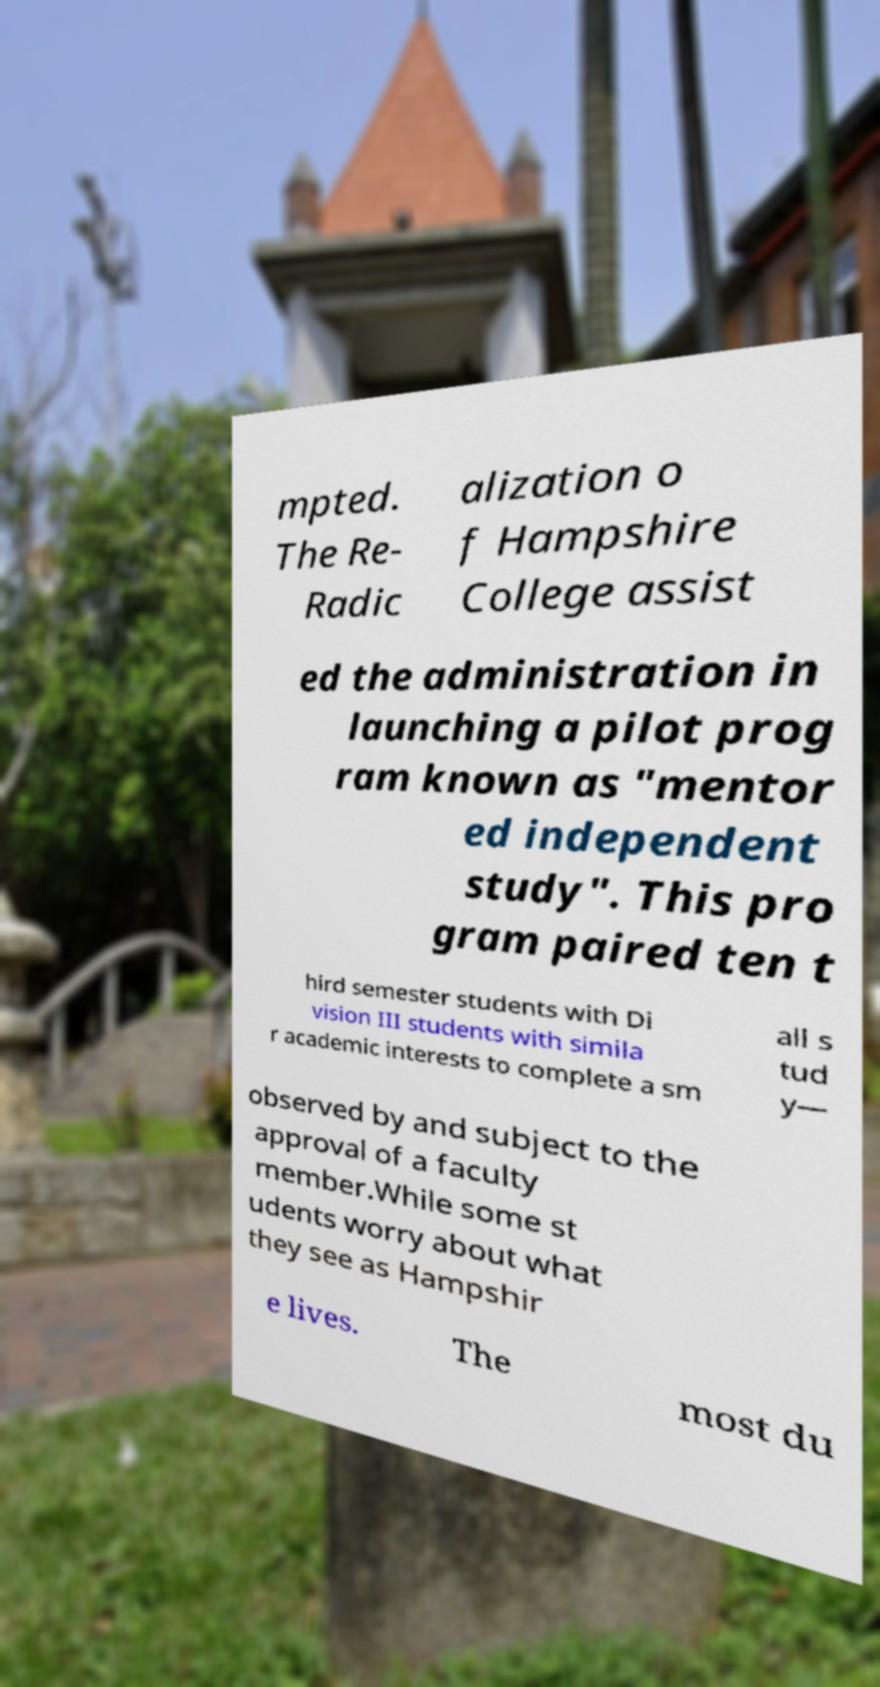Can you accurately transcribe the text from the provided image for me? mpted. The Re- Radic alization o f Hampshire College assist ed the administration in launching a pilot prog ram known as "mentor ed independent study". This pro gram paired ten t hird semester students with Di vision III students with simila r academic interests to complete a sm all s tud y— observed by and subject to the approval of a faculty member.While some st udents worry about what they see as Hampshir e lives. The most du 